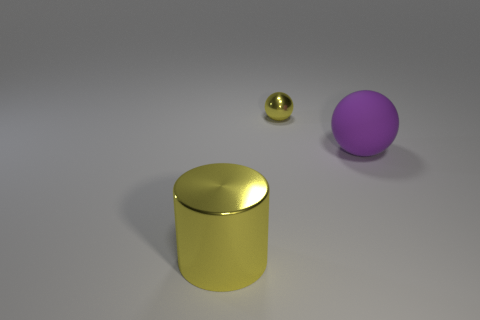Add 3 big purple rubber objects. How many objects exist? 6 Subtract all spheres. How many objects are left? 1 Subtract all metal cubes. Subtract all big rubber objects. How many objects are left? 2 Add 3 yellow metal cylinders. How many yellow metal cylinders are left? 4 Add 3 large matte things. How many large matte things exist? 4 Subtract 0 red balls. How many objects are left? 3 